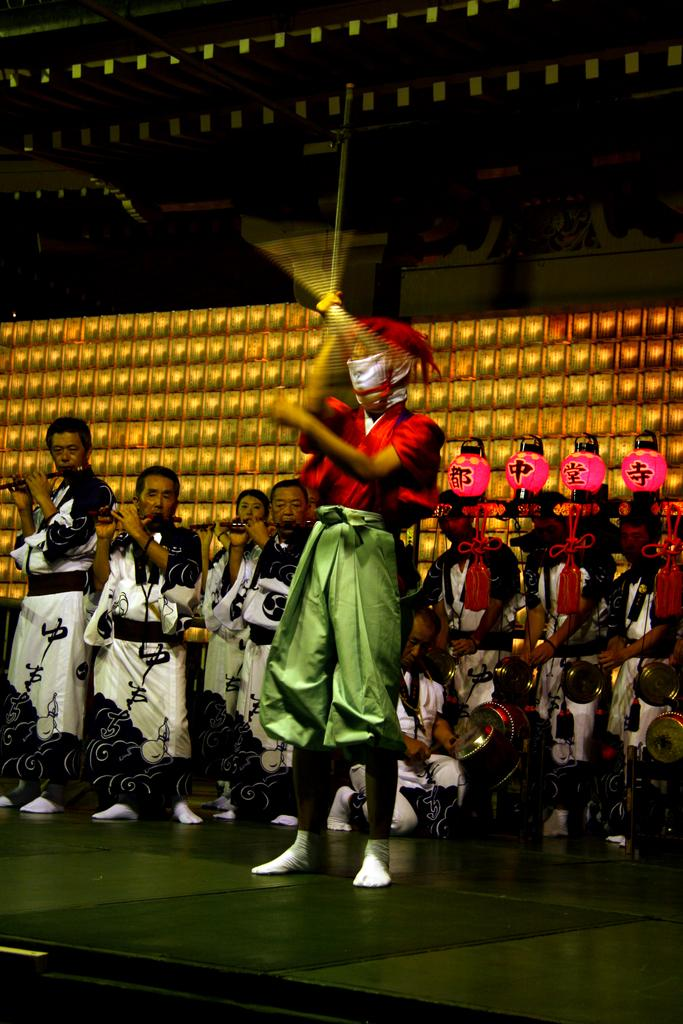How many people are in the image? There is a group of people in the image, but the exact number is not specified. What are some of the people doing in the image? Some people are playing musical instruments in the image. What can be seen in the background of the image? There are lights and paper lanterns in the background of the image. How many apples are hanging from the lights in the image? There are no apples present in the image; the lights and paper lanterns are the only visible objects in the background. 